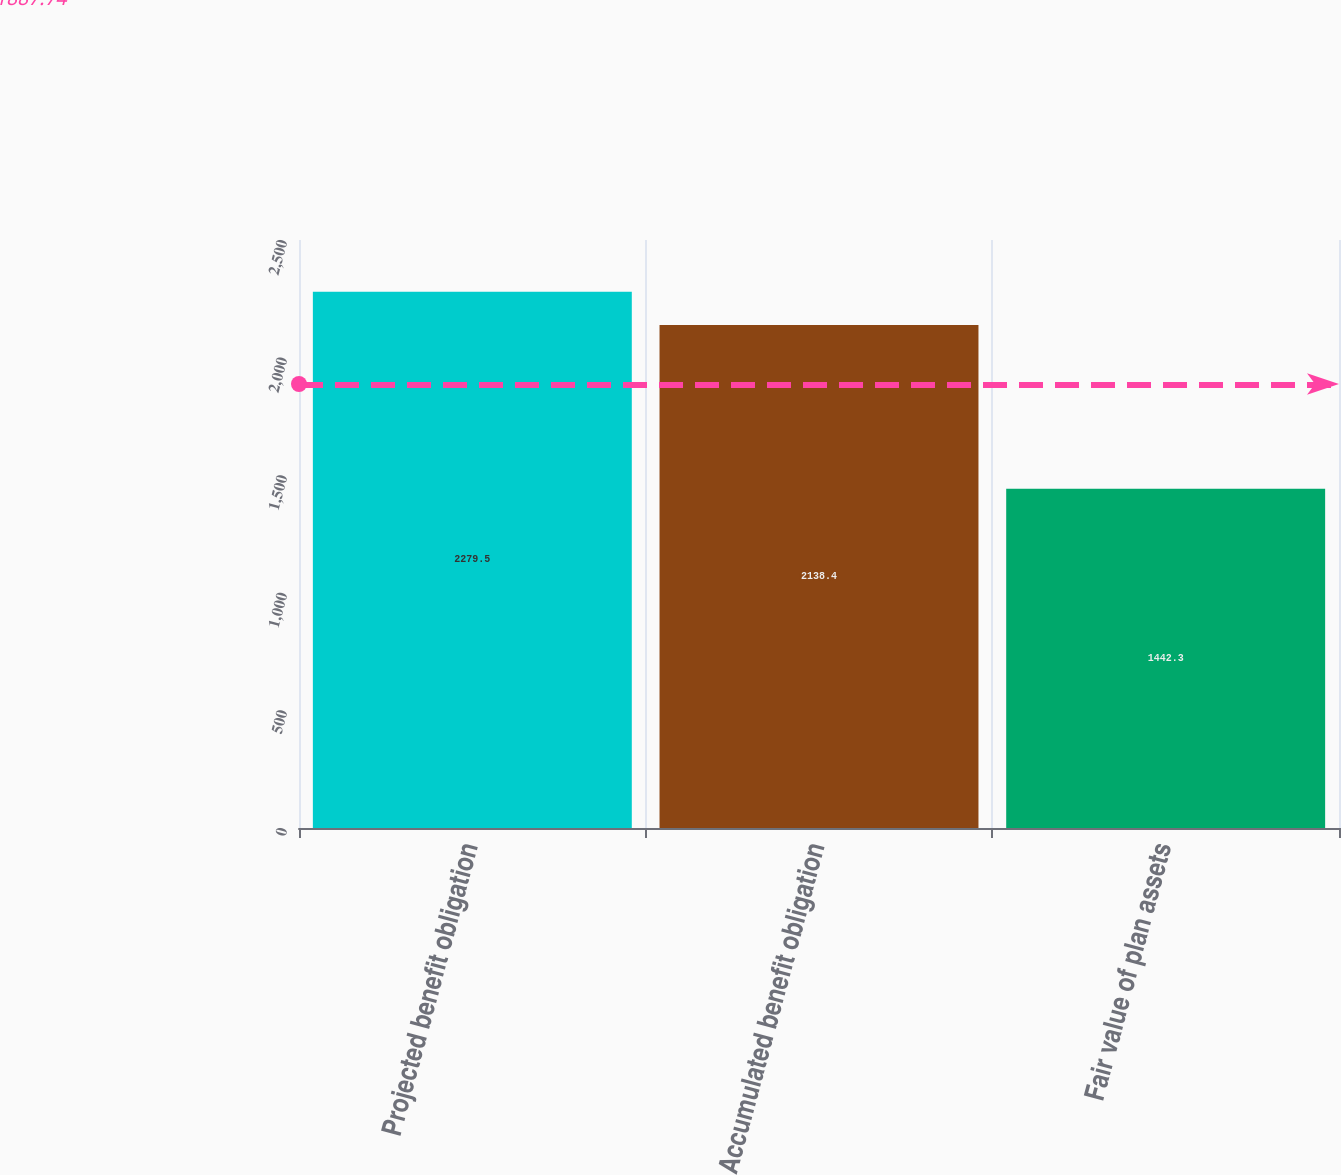<chart> <loc_0><loc_0><loc_500><loc_500><bar_chart><fcel>Projected benefit obligation<fcel>Accumulated benefit obligation<fcel>Fair value of plan assets<nl><fcel>2279.5<fcel>2138.4<fcel>1442.3<nl></chart> 